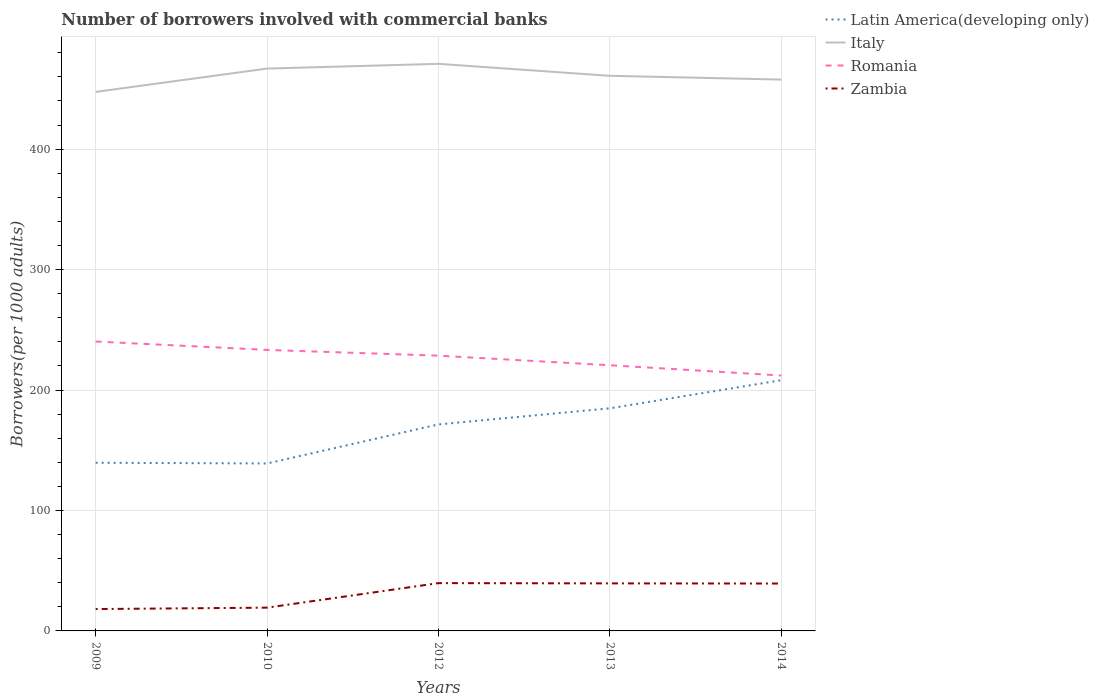How many different coloured lines are there?
Provide a succinct answer. 4. Is the number of lines equal to the number of legend labels?
Offer a very short reply. Yes. Across all years, what is the maximum number of borrowers involved with commercial banks in Zambia?
Your answer should be compact. 18.15. In which year was the number of borrowers involved with commercial banks in Romania maximum?
Give a very brief answer. 2014. What is the total number of borrowers involved with commercial banks in Romania in the graph?
Provide a short and direct response. 12.74. What is the difference between the highest and the second highest number of borrowers involved with commercial banks in Romania?
Offer a very short reply. 28.22. What is the difference between the highest and the lowest number of borrowers involved with commercial banks in Latin America(developing only)?
Provide a succinct answer. 3. Is the number of borrowers involved with commercial banks in Italy strictly greater than the number of borrowers involved with commercial banks in Romania over the years?
Provide a succinct answer. No. How many years are there in the graph?
Give a very brief answer. 5. What is the difference between two consecutive major ticks on the Y-axis?
Ensure brevity in your answer.  100. How many legend labels are there?
Make the answer very short. 4. What is the title of the graph?
Make the answer very short. Number of borrowers involved with commercial banks. What is the label or title of the X-axis?
Ensure brevity in your answer.  Years. What is the label or title of the Y-axis?
Your response must be concise. Borrowers(per 1000 adults). What is the Borrowers(per 1000 adults) of Latin America(developing only) in 2009?
Provide a succinct answer. 139.62. What is the Borrowers(per 1000 adults) of Italy in 2009?
Your response must be concise. 447.49. What is the Borrowers(per 1000 adults) of Romania in 2009?
Give a very brief answer. 240.26. What is the Borrowers(per 1000 adults) of Zambia in 2009?
Offer a very short reply. 18.15. What is the Borrowers(per 1000 adults) of Latin America(developing only) in 2010?
Offer a very short reply. 139.02. What is the Borrowers(per 1000 adults) in Italy in 2010?
Give a very brief answer. 466.85. What is the Borrowers(per 1000 adults) in Romania in 2010?
Your answer should be very brief. 233.3. What is the Borrowers(per 1000 adults) of Zambia in 2010?
Give a very brief answer. 19.32. What is the Borrowers(per 1000 adults) of Latin America(developing only) in 2012?
Ensure brevity in your answer.  171.43. What is the Borrowers(per 1000 adults) of Italy in 2012?
Your answer should be compact. 470.79. What is the Borrowers(per 1000 adults) in Romania in 2012?
Give a very brief answer. 228.51. What is the Borrowers(per 1000 adults) in Zambia in 2012?
Your answer should be compact. 39.68. What is the Borrowers(per 1000 adults) in Latin America(developing only) in 2013?
Keep it short and to the point. 184.81. What is the Borrowers(per 1000 adults) of Italy in 2013?
Your response must be concise. 460.84. What is the Borrowers(per 1000 adults) of Romania in 2013?
Ensure brevity in your answer.  220.56. What is the Borrowers(per 1000 adults) in Zambia in 2013?
Make the answer very short. 39.47. What is the Borrowers(per 1000 adults) of Latin America(developing only) in 2014?
Offer a very short reply. 208.14. What is the Borrowers(per 1000 adults) in Italy in 2014?
Keep it short and to the point. 457.72. What is the Borrowers(per 1000 adults) in Romania in 2014?
Make the answer very short. 212.04. What is the Borrowers(per 1000 adults) of Zambia in 2014?
Ensure brevity in your answer.  39.34. Across all years, what is the maximum Borrowers(per 1000 adults) in Latin America(developing only)?
Make the answer very short. 208.14. Across all years, what is the maximum Borrowers(per 1000 adults) in Italy?
Give a very brief answer. 470.79. Across all years, what is the maximum Borrowers(per 1000 adults) in Romania?
Give a very brief answer. 240.26. Across all years, what is the maximum Borrowers(per 1000 adults) in Zambia?
Provide a short and direct response. 39.68. Across all years, what is the minimum Borrowers(per 1000 adults) of Latin America(developing only)?
Give a very brief answer. 139.02. Across all years, what is the minimum Borrowers(per 1000 adults) in Italy?
Your answer should be very brief. 447.49. Across all years, what is the minimum Borrowers(per 1000 adults) of Romania?
Make the answer very short. 212.04. Across all years, what is the minimum Borrowers(per 1000 adults) in Zambia?
Offer a very short reply. 18.15. What is the total Borrowers(per 1000 adults) in Latin America(developing only) in the graph?
Make the answer very short. 843.01. What is the total Borrowers(per 1000 adults) of Italy in the graph?
Keep it short and to the point. 2303.69. What is the total Borrowers(per 1000 adults) of Romania in the graph?
Offer a very short reply. 1134.68. What is the total Borrowers(per 1000 adults) of Zambia in the graph?
Provide a short and direct response. 155.96. What is the difference between the Borrowers(per 1000 adults) in Latin America(developing only) in 2009 and that in 2010?
Provide a short and direct response. 0.61. What is the difference between the Borrowers(per 1000 adults) of Italy in 2009 and that in 2010?
Give a very brief answer. -19.36. What is the difference between the Borrowers(per 1000 adults) in Romania in 2009 and that in 2010?
Provide a succinct answer. 6.96. What is the difference between the Borrowers(per 1000 adults) of Zambia in 2009 and that in 2010?
Offer a very short reply. -1.17. What is the difference between the Borrowers(per 1000 adults) in Latin America(developing only) in 2009 and that in 2012?
Make the answer very short. -31.81. What is the difference between the Borrowers(per 1000 adults) of Italy in 2009 and that in 2012?
Offer a terse response. -23.3. What is the difference between the Borrowers(per 1000 adults) of Romania in 2009 and that in 2012?
Your answer should be very brief. 11.75. What is the difference between the Borrowers(per 1000 adults) of Zambia in 2009 and that in 2012?
Provide a succinct answer. -21.52. What is the difference between the Borrowers(per 1000 adults) of Latin America(developing only) in 2009 and that in 2013?
Offer a very short reply. -45.18. What is the difference between the Borrowers(per 1000 adults) in Italy in 2009 and that in 2013?
Keep it short and to the point. -13.35. What is the difference between the Borrowers(per 1000 adults) in Romania in 2009 and that in 2013?
Your answer should be very brief. 19.7. What is the difference between the Borrowers(per 1000 adults) of Zambia in 2009 and that in 2013?
Give a very brief answer. -21.31. What is the difference between the Borrowers(per 1000 adults) of Latin America(developing only) in 2009 and that in 2014?
Your answer should be very brief. -68.51. What is the difference between the Borrowers(per 1000 adults) in Italy in 2009 and that in 2014?
Provide a succinct answer. -10.23. What is the difference between the Borrowers(per 1000 adults) in Romania in 2009 and that in 2014?
Your response must be concise. 28.22. What is the difference between the Borrowers(per 1000 adults) in Zambia in 2009 and that in 2014?
Offer a terse response. -21.19. What is the difference between the Borrowers(per 1000 adults) in Latin America(developing only) in 2010 and that in 2012?
Give a very brief answer. -32.42. What is the difference between the Borrowers(per 1000 adults) of Italy in 2010 and that in 2012?
Ensure brevity in your answer.  -3.94. What is the difference between the Borrowers(per 1000 adults) of Romania in 2010 and that in 2012?
Provide a succinct answer. 4.79. What is the difference between the Borrowers(per 1000 adults) of Zambia in 2010 and that in 2012?
Give a very brief answer. -20.36. What is the difference between the Borrowers(per 1000 adults) of Latin America(developing only) in 2010 and that in 2013?
Offer a terse response. -45.79. What is the difference between the Borrowers(per 1000 adults) in Italy in 2010 and that in 2013?
Your answer should be compact. 6.01. What is the difference between the Borrowers(per 1000 adults) of Romania in 2010 and that in 2013?
Give a very brief answer. 12.74. What is the difference between the Borrowers(per 1000 adults) in Zambia in 2010 and that in 2013?
Provide a succinct answer. -20.14. What is the difference between the Borrowers(per 1000 adults) of Latin America(developing only) in 2010 and that in 2014?
Make the answer very short. -69.12. What is the difference between the Borrowers(per 1000 adults) in Italy in 2010 and that in 2014?
Your answer should be compact. 9.13. What is the difference between the Borrowers(per 1000 adults) in Romania in 2010 and that in 2014?
Your response must be concise. 21.26. What is the difference between the Borrowers(per 1000 adults) in Zambia in 2010 and that in 2014?
Your response must be concise. -20.02. What is the difference between the Borrowers(per 1000 adults) of Latin America(developing only) in 2012 and that in 2013?
Your answer should be very brief. -13.38. What is the difference between the Borrowers(per 1000 adults) of Italy in 2012 and that in 2013?
Your answer should be very brief. 9.95. What is the difference between the Borrowers(per 1000 adults) in Romania in 2012 and that in 2013?
Your answer should be very brief. 7.95. What is the difference between the Borrowers(per 1000 adults) in Zambia in 2012 and that in 2013?
Offer a very short reply. 0.21. What is the difference between the Borrowers(per 1000 adults) of Latin America(developing only) in 2012 and that in 2014?
Offer a terse response. -36.7. What is the difference between the Borrowers(per 1000 adults) of Italy in 2012 and that in 2014?
Give a very brief answer. 13.07. What is the difference between the Borrowers(per 1000 adults) of Romania in 2012 and that in 2014?
Provide a short and direct response. 16.47. What is the difference between the Borrowers(per 1000 adults) of Zambia in 2012 and that in 2014?
Offer a terse response. 0.34. What is the difference between the Borrowers(per 1000 adults) in Latin America(developing only) in 2013 and that in 2014?
Offer a terse response. -23.33. What is the difference between the Borrowers(per 1000 adults) of Italy in 2013 and that in 2014?
Your answer should be very brief. 3.12. What is the difference between the Borrowers(per 1000 adults) in Romania in 2013 and that in 2014?
Your answer should be compact. 8.52. What is the difference between the Borrowers(per 1000 adults) of Zambia in 2013 and that in 2014?
Offer a terse response. 0.13. What is the difference between the Borrowers(per 1000 adults) in Latin America(developing only) in 2009 and the Borrowers(per 1000 adults) in Italy in 2010?
Ensure brevity in your answer.  -327.23. What is the difference between the Borrowers(per 1000 adults) of Latin America(developing only) in 2009 and the Borrowers(per 1000 adults) of Romania in 2010?
Provide a succinct answer. -93.68. What is the difference between the Borrowers(per 1000 adults) in Latin America(developing only) in 2009 and the Borrowers(per 1000 adults) in Zambia in 2010?
Your answer should be compact. 120.3. What is the difference between the Borrowers(per 1000 adults) of Italy in 2009 and the Borrowers(per 1000 adults) of Romania in 2010?
Make the answer very short. 214.19. What is the difference between the Borrowers(per 1000 adults) in Italy in 2009 and the Borrowers(per 1000 adults) in Zambia in 2010?
Offer a very short reply. 428.17. What is the difference between the Borrowers(per 1000 adults) of Romania in 2009 and the Borrowers(per 1000 adults) of Zambia in 2010?
Keep it short and to the point. 220.94. What is the difference between the Borrowers(per 1000 adults) of Latin America(developing only) in 2009 and the Borrowers(per 1000 adults) of Italy in 2012?
Make the answer very short. -331.17. What is the difference between the Borrowers(per 1000 adults) of Latin America(developing only) in 2009 and the Borrowers(per 1000 adults) of Romania in 2012?
Your answer should be very brief. -88.89. What is the difference between the Borrowers(per 1000 adults) in Latin America(developing only) in 2009 and the Borrowers(per 1000 adults) in Zambia in 2012?
Offer a very short reply. 99.95. What is the difference between the Borrowers(per 1000 adults) in Italy in 2009 and the Borrowers(per 1000 adults) in Romania in 2012?
Your answer should be very brief. 218.98. What is the difference between the Borrowers(per 1000 adults) in Italy in 2009 and the Borrowers(per 1000 adults) in Zambia in 2012?
Keep it short and to the point. 407.81. What is the difference between the Borrowers(per 1000 adults) of Romania in 2009 and the Borrowers(per 1000 adults) of Zambia in 2012?
Ensure brevity in your answer.  200.58. What is the difference between the Borrowers(per 1000 adults) in Latin America(developing only) in 2009 and the Borrowers(per 1000 adults) in Italy in 2013?
Your response must be concise. -321.22. What is the difference between the Borrowers(per 1000 adults) of Latin America(developing only) in 2009 and the Borrowers(per 1000 adults) of Romania in 2013?
Offer a terse response. -80.94. What is the difference between the Borrowers(per 1000 adults) in Latin America(developing only) in 2009 and the Borrowers(per 1000 adults) in Zambia in 2013?
Ensure brevity in your answer.  100.16. What is the difference between the Borrowers(per 1000 adults) in Italy in 2009 and the Borrowers(per 1000 adults) in Romania in 2013?
Your response must be concise. 226.93. What is the difference between the Borrowers(per 1000 adults) of Italy in 2009 and the Borrowers(per 1000 adults) of Zambia in 2013?
Ensure brevity in your answer.  408.02. What is the difference between the Borrowers(per 1000 adults) of Romania in 2009 and the Borrowers(per 1000 adults) of Zambia in 2013?
Provide a short and direct response. 200.79. What is the difference between the Borrowers(per 1000 adults) in Latin America(developing only) in 2009 and the Borrowers(per 1000 adults) in Italy in 2014?
Ensure brevity in your answer.  -318.1. What is the difference between the Borrowers(per 1000 adults) of Latin America(developing only) in 2009 and the Borrowers(per 1000 adults) of Romania in 2014?
Offer a terse response. -72.42. What is the difference between the Borrowers(per 1000 adults) of Latin America(developing only) in 2009 and the Borrowers(per 1000 adults) of Zambia in 2014?
Your answer should be very brief. 100.28. What is the difference between the Borrowers(per 1000 adults) of Italy in 2009 and the Borrowers(per 1000 adults) of Romania in 2014?
Offer a terse response. 235.45. What is the difference between the Borrowers(per 1000 adults) of Italy in 2009 and the Borrowers(per 1000 adults) of Zambia in 2014?
Ensure brevity in your answer.  408.15. What is the difference between the Borrowers(per 1000 adults) of Romania in 2009 and the Borrowers(per 1000 adults) of Zambia in 2014?
Offer a very short reply. 200.92. What is the difference between the Borrowers(per 1000 adults) of Latin America(developing only) in 2010 and the Borrowers(per 1000 adults) of Italy in 2012?
Provide a short and direct response. -331.77. What is the difference between the Borrowers(per 1000 adults) in Latin America(developing only) in 2010 and the Borrowers(per 1000 adults) in Romania in 2012?
Offer a terse response. -89.5. What is the difference between the Borrowers(per 1000 adults) in Latin America(developing only) in 2010 and the Borrowers(per 1000 adults) in Zambia in 2012?
Ensure brevity in your answer.  99.34. What is the difference between the Borrowers(per 1000 adults) of Italy in 2010 and the Borrowers(per 1000 adults) of Romania in 2012?
Provide a succinct answer. 238.34. What is the difference between the Borrowers(per 1000 adults) of Italy in 2010 and the Borrowers(per 1000 adults) of Zambia in 2012?
Your answer should be compact. 427.17. What is the difference between the Borrowers(per 1000 adults) of Romania in 2010 and the Borrowers(per 1000 adults) of Zambia in 2012?
Provide a short and direct response. 193.62. What is the difference between the Borrowers(per 1000 adults) of Latin America(developing only) in 2010 and the Borrowers(per 1000 adults) of Italy in 2013?
Give a very brief answer. -321.83. What is the difference between the Borrowers(per 1000 adults) of Latin America(developing only) in 2010 and the Borrowers(per 1000 adults) of Romania in 2013?
Your answer should be very brief. -81.55. What is the difference between the Borrowers(per 1000 adults) in Latin America(developing only) in 2010 and the Borrowers(per 1000 adults) in Zambia in 2013?
Make the answer very short. 99.55. What is the difference between the Borrowers(per 1000 adults) in Italy in 2010 and the Borrowers(per 1000 adults) in Romania in 2013?
Provide a succinct answer. 246.29. What is the difference between the Borrowers(per 1000 adults) of Italy in 2010 and the Borrowers(per 1000 adults) of Zambia in 2013?
Ensure brevity in your answer.  427.38. What is the difference between the Borrowers(per 1000 adults) in Romania in 2010 and the Borrowers(per 1000 adults) in Zambia in 2013?
Your answer should be compact. 193.83. What is the difference between the Borrowers(per 1000 adults) in Latin America(developing only) in 2010 and the Borrowers(per 1000 adults) in Italy in 2014?
Offer a terse response. -318.71. What is the difference between the Borrowers(per 1000 adults) of Latin America(developing only) in 2010 and the Borrowers(per 1000 adults) of Romania in 2014?
Provide a succinct answer. -73.03. What is the difference between the Borrowers(per 1000 adults) in Latin America(developing only) in 2010 and the Borrowers(per 1000 adults) in Zambia in 2014?
Offer a very short reply. 99.68. What is the difference between the Borrowers(per 1000 adults) of Italy in 2010 and the Borrowers(per 1000 adults) of Romania in 2014?
Make the answer very short. 254.81. What is the difference between the Borrowers(per 1000 adults) in Italy in 2010 and the Borrowers(per 1000 adults) in Zambia in 2014?
Keep it short and to the point. 427.51. What is the difference between the Borrowers(per 1000 adults) in Romania in 2010 and the Borrowers(per 1000 adults) in Zambia in 2014?
Your response must be concise. 193.96. What is the difference between the Borrowers(per 1000 adults) in Latin America(developing only) in 2012 and the Borrowers(per 1000 adults) in Italy in 2013?
Your answer should be compact. -289.41. What is the difference between the Borrowers(per 1000 adults) in Latin America(developing only) in 2012 and the Borrowers(per 1000 adults) in Romania in 2013?
Your response must be concise. -49.13. What is the difference between the Borrowers(per 1000 adults) in Latin America(developing only) in 2012 and the Borrowers(per 1000 adults) in Zambia in 2013?
Ensure brevity in your answer.  131.97. What is the difference between the Borrowers(per 1000 adults) of Italy in 2012 and the Borrowers(per 1000 adults) of Romania in 2013?
Give a very brief answer. 250.23. What is the difference between the Borrowers(per 1000 adults) of Italy in 2012 and the Borrowers(per 1000 adults) of Zambia in 2013?
Your response must be concise. 431.32. What is the difference between the Borrowers(per 1000 adults) of Romania in 2012 and the Borrowers(per 1000 adults) of Zambia in 2013?
Provide a short and direct response. 189.05. What is the difference between the Borrowers(per 1000 adults) in Latin America(developing only) in 2012 and the Borrowers(per 1000 adults) in Italy in 2014?
Give a very brief answer. -286.29. What is the difference between the Borrowers(per 1000 adults) in Latin America(developing only) in 2012 and the Borrowers(per 1000 adults) in Romania in 2014?
Give a very brief answer. -40.61. What is the difference between the Borrowers(per 1000 adults) of Latin America(developing only) in 2012 and the Borrowers(per 1000 adults) of Zambia in 2014?
Your answer should be very brief. 132.09. What is the difference between the Borrowers(per 1000 adults) in Italy in 2012 and the Borrowers(per 1000 adults) in Romania in 2014?
Ensure brevity in your answer.  258.75. What is the difference between the Borrowers(per 1000 adults) of Italy in 2012 and the Borrowers(per 1000 adults) of Zambia in 2014?
Give a very brief answer. 431.45. What is the difference between the Borrowers(per 1000 adults) of Romania in 2012 and the Borrowers(per 1000 adults) of Zambia in 2014?
Offer a very short reply. 189.17. What is the difference between the Borrowers(per 1000 adults) of Latin America(developing only) in 2013 and the Borrowers(per 1000 adults) of Italy in 2014?
Provide a short and direct response. -272.92. What is the difference between the Borrowers(per 1000 adults) of Latin America(developing only) in 2013 and the Borrowers(per 1000 adults) of Romania in 2014?
Provide a short and direct response. -27.23. What is the difference between the Borrowers(per 1000 adults) of Latin America(developing only) in 2013 and the Borrowers(per 1000 adults) of Zambia in 2014?
Provide a succinct answer. 145.47. What is the difference between the Borrowers(per 1000 adults) in Italy in 2013 and the Borrowers(per 1000 adults) in Romania in 2014?
Keep it short and to the point. 248.8. What is the difference between the Borrowers(per 1000 adults) of Italy in 2013 and the Borrowers(per 1000 adults) of Zambia in 2014?
Keep it short and to the point. 421.5. What is the difference between the Borrowers(per 1000 adults) in Romania in 2013 and the Borrowers(per 1000 adults) in Zambia in 2014?
Your answer should be very brief. 181.22. What is the average Borrowers(per 1000 adults) in Latin America(developing only) per year?
Offer a very short reply. 168.6. What is the average Borrowers(per 1000 adults) of Italy per year?
Give a very brief answer. 460.74. What is the average Borrowers(per 1000 adults) in Romania per year?
Provide a succinct answer. 226.94. What is the average Borrowers(per 1000 adults) in Zambia per year?
Ensure brevity in your answer.  31.19. In the year 2009, what is the difference between the Borrowers(per 1000 adults) of Latin America(developing only) and Borrowers(per 1000 adults) of Italy?
Ensure brevity in your answer.  -307.87. In the year 2009, what is the difference between the Borrowers(per 1000 adults) in Latin America(developing only) and Borrowers(per 1000 adults) in Romania?
Keep it short and to the point. -100.64. In the year 2009, what is the difference between the Borrowers(per 1000 adults) in Latin America(developing only) and Borrowers(per 1000 adults) in Zambia?
Give a very brief answer. 121.47. In the year 2009, what is the difference between the Borrowers(per 1000 adults) in Italy and Borrowers(per 1000 adults) in Romania?
Provide a short and direct response. 207.23. In the year 2009, what is the difference between the Borrowers(per 1000 adults) in Italy and Borrowers(per 1000 adults) in Zambia?
Your answer should be compact. 429.34. In the year 2009, what is the difference between the Borrowers(per 1000 adults) of Romania and Borrowers(per 1000 adults) of Zambia?
Offer a very short reply. 222.11. In the year 2010, what is the difference between the Borrowers(per 1000 adults) in Latin America(developing only) and Borrowers(per 1000 adults) in Italy?
Your response must be concise. -327.84. In the year 2010, what is the difference between the Borrowers(per 1000 adults) of Latin America(developing only) and Borrowers(per 1000 adults) of Romania?
Provide a succinct answer. -94.28. In the year 2010, what is the difference between the Borrowers(per 1000 adults) in Latin America(developing only) and Borrowers(per 1000 adults) in Zambia?
Provide a succinct answer. 119.69. In the year 2010, what is the difference between the Borrowers(per 1000 adults) of Italy and Borrowers(per 1000 adults) of Romania?
Your answer should be very brief. 233.55. In the year 2010, what is the difference between the Borrowers(per 1000 adults) in Italy and Borrowers(per 1000 adults) in Zambia?
Offer a terse response. 447.53. In the year 2010, what is the difference between the Borrowers(per 1000 adults) in Romania and Borrowers(per 1000 adults) in Zambia?
Offer a terse response. 213.98. In the year 2012, what is the difference between the Borrowers(per 1000 adults) in Latin America(developing only) and Borrowers(per 1000 adults) in Italy?
Keep it short and to the point. -299.36. In the year 2012, what is the difference between the Borrowers(per 1000 adults) of Latin America(developing only) and Borrowers(per 1000 adults) of Romania?
Ensure brevity in your answer.  -57.08. In the year 2012, what is the difference between the Borrowers(per 1000 adults) of Latin America(developing only) and Borrowers(per 1000 adults) of Zambia?
Provide a succinct answer. 131.75. In the year 2012, what is the difference between the Borrowers(per 1000 adults) in Italy and Borrowers(per 1000 adults) in Romania?
Your answer should be compact. 242.28. In the year 2012, what is the difference between the Borrowers(per 1000 adults) of Italy and Borrowers(per 1000 adults) of Zambia?
Give a very brief answer. 431.11. In the year 2012, what is the difference between the Borrowers(per 1000 adults) in Romania and Borrowers(per 1000 adults) in Zambia?
Keep it short and to the point. 188.83. In the year 2013, what is the difference between the Borrowers(per 1000 adults) of Latin America(developing only) and Borrowers(per 1000 adults) of Italy?
Offer a terse response. -276.03. In the year 2013, what is the difference between the Borrowers(per 1000 adults) of Latin America(developing only) and Borrowers(per 1000 adults) of Romania?
Your response must be concise. -35.76. In the year 2013, what is the difference between the Borrowers(per 1000 adults) of Latin America(developing only) and Borrowers(per 1000 adults) of Zambia?
Your answer should be compact. 145.34. In the year 2013, what is the difference between the Borrowers(per 1000 adults) in Italy and Borrowers(per 1000 adults) in Romania?
Provide a succinct answer. 240.28. In the year 2013, what is the difference between the Borrowers(per 1000 adults) in Italy and Borrowers(per 1000 adults) in Zambia?
Your answer should be compact. 421.37. In the year 2013, what is the difference between the Borrowers(per 1000 adults) of Romania and Borrowers(per 1000 adults) of Zambia?
Your response must be concise. 181.1. In the year 2014, what is the difference between the Borrowers(per 1000 adults) in Latin America(developing only) and Borrowers(per 1000 adults) in Italy?
Make the answer very short. -249.59. In the year 2014, what is the difference between the Borrowers(per 1000 adults) in Latin America(developing only) and Borrowers(per 1000 adults) in Romania?
Your answer should be very brief. -3.91. In the year 2014, what is the difference between the Borrowers(per 1000 adults) in Latin America(developing only) and Borrowers(per 1000 adults) in Zambia?
Your answer should be compact. 168.8. In the year 2014, what is the difference between the Borrowers(per 1000 adults) of Italy and Borrowers(per 1000 adults) of Romania?
Ensure brevity in your answer.  245.68. In the year 2014, what is the difference between the Borrowers(per 1000 adults) of Italy and Borrowers(per 1000 adults) of Zambia?
Offer a very short reply. 418.38. In the year 2014, what is the difference between the Borrowers(per 1000 adults) in Romania and Borrowers(per 1000 adults) in Zambia?
Offer a terse response. 172.7. What is the ratio of the Borrowers(per 1000 adults) of Latin America(developing only) in 2009 to that in 2010?
Offer a terse response. 1. What is the ratio of the Borrowers(per 1000 adults) in Italy in 2009 to that in 2010?
Provide a short and direct response. 0.96. What is the ratio of the Borrowers(per 1000 adults) in Romania in 2009 to that in 2010?
Your response must be concise. 1.03. What is the ratio of the Borrowers(per 1000 adults) of Zambia in 2009 to that in 2010?
Your answer should be compact. 0.94. What is the ratio of the Borrowers(per 1000 adults) in Latin America(developing only) in 2009 to that in 2012?
Provide a short and direct response. 0.81. What is the ratio of the Borrowers(per 1000 adults) of Italy in 2009 to that in 2012?
Your response must be concise. 0.95. What is the ratio of the Borrowers(per 1000 adults) of Romania in 2009 to that in 2012?
Offer a very short reply. 1.05. What is the ratio of the Borrowers(per 1000 adults) in Zambia in 2009 to that in 2012?
Your answer should be compact. 0.46. What is the ratio of the Borrowers(per 1000 adults) in Latin America(developing only) in 2009 to that in 2013?
Make the answer very short. 0.76. What is the ratio of the Borrowers(per 1000 adults) of Romania in 2009 to that in 2013?
Offer a very short reply. 1.09. What is the ratio of the Borrowers(per 1000 adults) of Zambia in 2009 to that in 2013?
Offer a very short reply. 0.46. What is the ratio of the Borrowers(per 1000 adults) of Latin America(developing only) in 2009 to that in 2014?
Offer a terse response. 0.67. What is the ratio of the Borrowers(per 1000 adults) of Italy in 2009 to that in 2014?
Your answer should be compact. 0.98. What is the ratio of the Borrowers(per 1000 adults) of Romania in 2009 to that in 2014?
Give a very brief answer. 1.13. What is the ratio of the Borrowers(per 1000 adults) in Zambia in 2009 to that in 2014?
Give a very brief answer. 0.46. What is the ratio of the Borrowers(per 1000 adults) of Latin America(developing only) in 2010 to that in 2012?
Make the answer very short. 0.81. What is the ratio of the Borrowers(per 1000 adults) in Italy in 2010 to that in 2012?
Give a very brief answer. 0.99. What is the ratio of the Borrowers(per 1000 adults) of Romania in 2010 to that in 2012?
Provide a short and direct response. 1.02. What is the ratio of the Borrowers(per 1000 adults) in Zambia in 2010 to that in 2012?
Your response must be concise. 0.49. What is the ratio of the Borrowers(per 1000 adults) of Latin America(developing only) in 2010 to that in 2013?
Offer a very short reply. 0.75. What is the ratio of the Borrowers(per 1000 adults) in Italy in 2010 to that in 2013?
Offer a terse response. 1.01. What is the ratio of the Borrowers(per 1000 adults) of Romania in 2010 to that in 2013?
Give a very brief answer. 1.06. What is the ratio of the Borrowers(per 1000 adults) of Zambia in 2010 to that in 2013?
Make the answer very short. 0.49. What is the ratio of the Borrowers(per 1000 adults) of Latin America(developing only) in 2010 to that in 2014?
Provide a succinct answer. 0.67. What is the ratio of the Borrowers(per 1000 adults) of Italy in 2010 to that in 2014?
Your answer should be very brief. 1.02. What is the ratio of the Borrowers(per 1000 adults) of Romania in 2010 to that in 2014?
Offer a terse response. 1.1. What is the ratio of the Borrowers(per 1000 adults) in Zambia in 2010 to that in 2014?
Your answer should be compact. 0.49. What is the ratio of the Borrowers(per 1000 adults) in Latin America(developing only) in 2012 to that in 2013?
Ensure brevity in your answer.  0.93. What is the ratio of the Borrowers(per 1000 adults) in Italy in 2012 to that in 2013?
Keep it short and to the point. 1.02. What is the ratio of the Borrowers(per 1000 adults) of Romania in 2012 to that in 2013?
Your response must be concise. 1.04. What is the ratio of the Borrowers(per 1000 adults) of Latin America(developing only) in 2012 to that in 2014?
Provide a succinct answer. 0.82. What is the ratio of the Borrowers(per 1000 adults) in Italy in 2012 to that in 2014?
Provide a short and direct response. 1.03. What is the ratio of the Borrowers(per 1000 adults) of Romania in 2012 to that in 2014?
Keep it short and to the point. 1.08. What is the ratio of the Borrowers(per 1000 adults) of Zambia in 2012 to that in 2014?
Provide a succinct answer. 1.01. What is the ratio of the Borrowers(per 1000 adults) of Latin America(developing only) in 2013 to that in 2014?
Offer a very short reply. 0.89. What is the ratio of the Borrowers(per 1000 adults) of Italy in 2013 to that in 2014?
Provide a short and direct response. 1.01. What is the ratio of the Borrowers(per 1000 adults) in Romania in 2013 to that in 2014?
Provide a short and direct response. 1.04. What is the ratio of the Borrowers(per 1000 adults) in Zambia in 2013 to that in 2014?
Your answer should be very brief. 1. What is the difference between the highest and the second highest Borrowers(per 1000 adults) of Latin America(developing only)?
Make the answer very short. 23.33. What is the difference between the highest and the second highest Borrowers(per 1000 adults) in Italy?
Your answer should be very brief. 3.94. What is the difference between the highest and the second highest Borrowers(per 1000 adults) of Romania?
Make the answer very short. 6.96. What is the difference between the highest and the second highest Borrowers(per 1000 adults) in Zambia?
Ensure brevity in your answer.  0.21. What is the difference between the highest and the lowest Borrowers(per 1000 adults) in Latin America(developing only)?
Give a very brief answer. 69.12. What is the difference between the highest and the lowest Borrowers(per 1000 adults) in Italy?
Provide a succinct answer. 23.3. What is the difference between the highest and the lowest Borrowers(per 1000 adults) of Romania?
Keep it short and to the point. 28.22. What is the difference between the highest and the lowest Borrowers(per 1000 adults) in Zambia?
Ensure brevity in your answer.  21.52. 